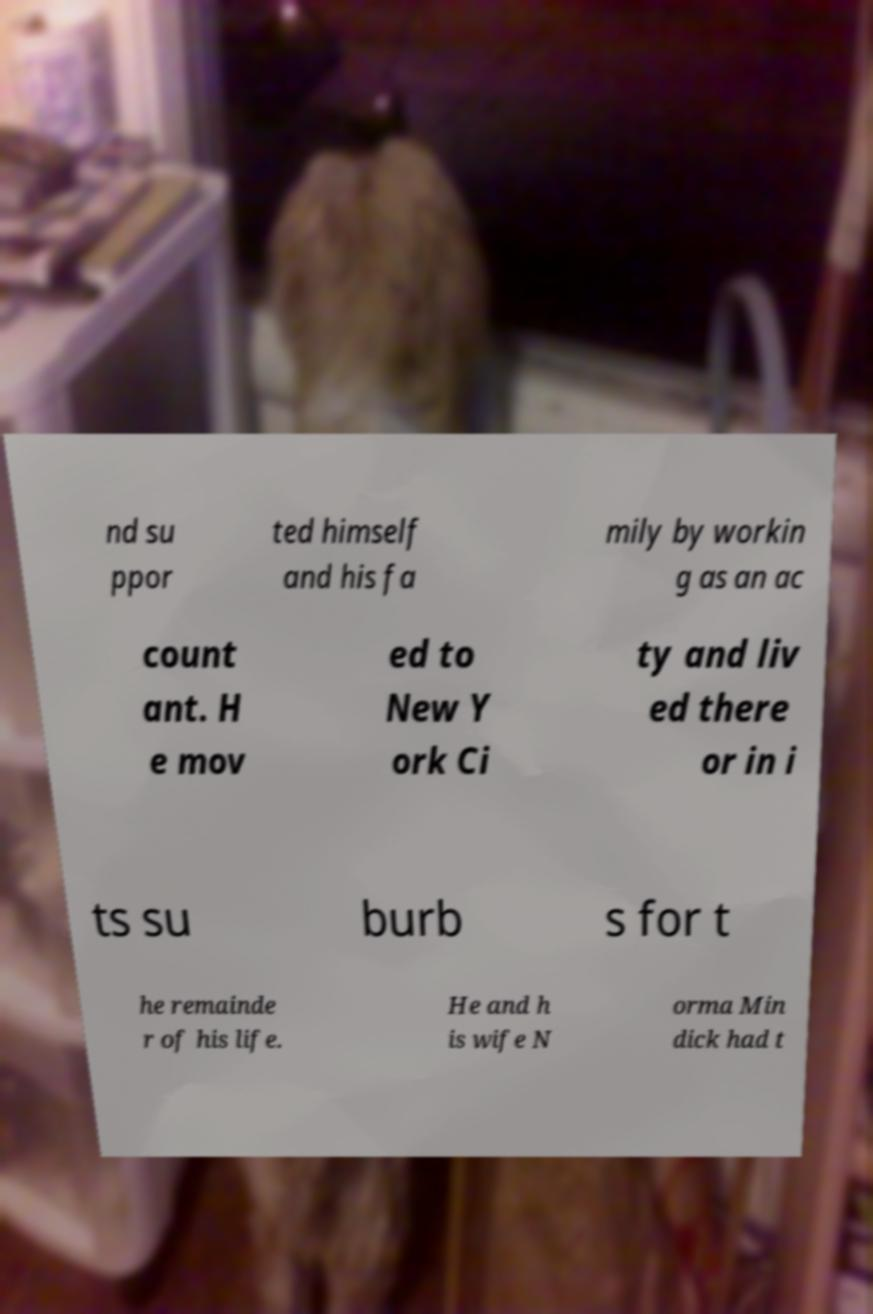There's text embedded in this image that I need extracted. Can you transcribe it verbatim? nd su ppor ted himself and his fa mily by workin g as an ac count ant. H e mov ed to New Y ork Ci ty and liv ed there or in i ts su burb s for t he remainde r of his life. He and h is wife N orma Min dick had t 